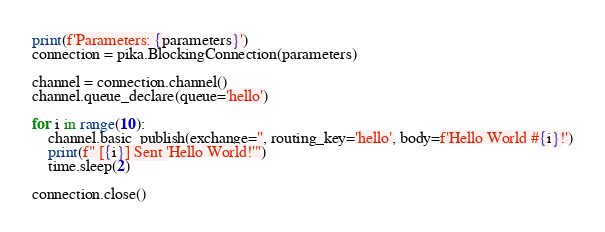Convert code to text. <code><loc_0><loc_0><loc_500><loc_500><_Python_>print(f'Parameters: {parameters}')
connection = pika.BlockingConnection(parameters)

channel = connection.channel()
channel.queue_declare(queue='hello')

for i in range(10):
    channel.basic_publish(exchange='', routing_key='hello', body=f'Hello World #{i}!')
    print(f" [{i}] Sent 'Hello World!'")
    time.sleep(2)

connection.close()</code> 